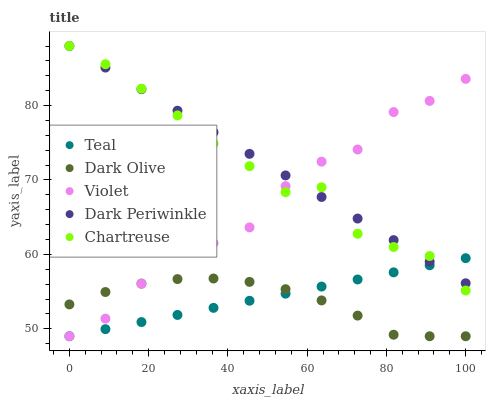Does Dark Olive have the minimum area under the curve?
Answer yes or no. Yes. Does Dark Periwinkle have the maximum area under the curve?
Answer yes or no. Yes. Does Dark Periwinkle have the minimum area under the curve?
Answer yes or no. No. Does Dark Olive have the maximum area under the curve?
Answer yes or no. No. Is Teal the smoothest?
Answer yes or no. Yes. Is Violet the roughest?
Answer yes or no. Yes. Is Dark Olive the smoothest?
Answer yes or no. No. Is Dark Olive the roughest?
Answer yes or no. No. Does Dark Olive have the lowest value?
Answer yes or no. Yes. Does Dark Periwinkle have the lowest value?
Answer yes or no. No. Does Dark Periwinkle have the highest value?
Answer yes or no. Yes. Does Dark Olive have the highest value?
Answer yes or no. No. Is Dark Olive less than Chartreuse?
Answer yes or no. Yes. Is Chartreuse greater than Dark Olive?
Answer yes or no. Yes. Does Dark Periwinkle intersect Violet?
Answer yes or no. Yes. Is Dark Periwinkle less than Violet?
Answer yes or no. No. Is Dark Periwinkle greater than Violet?
Answer yes or no. No. Does Dark Olive intersect Chartreuse?
Answer yes or no. No. 